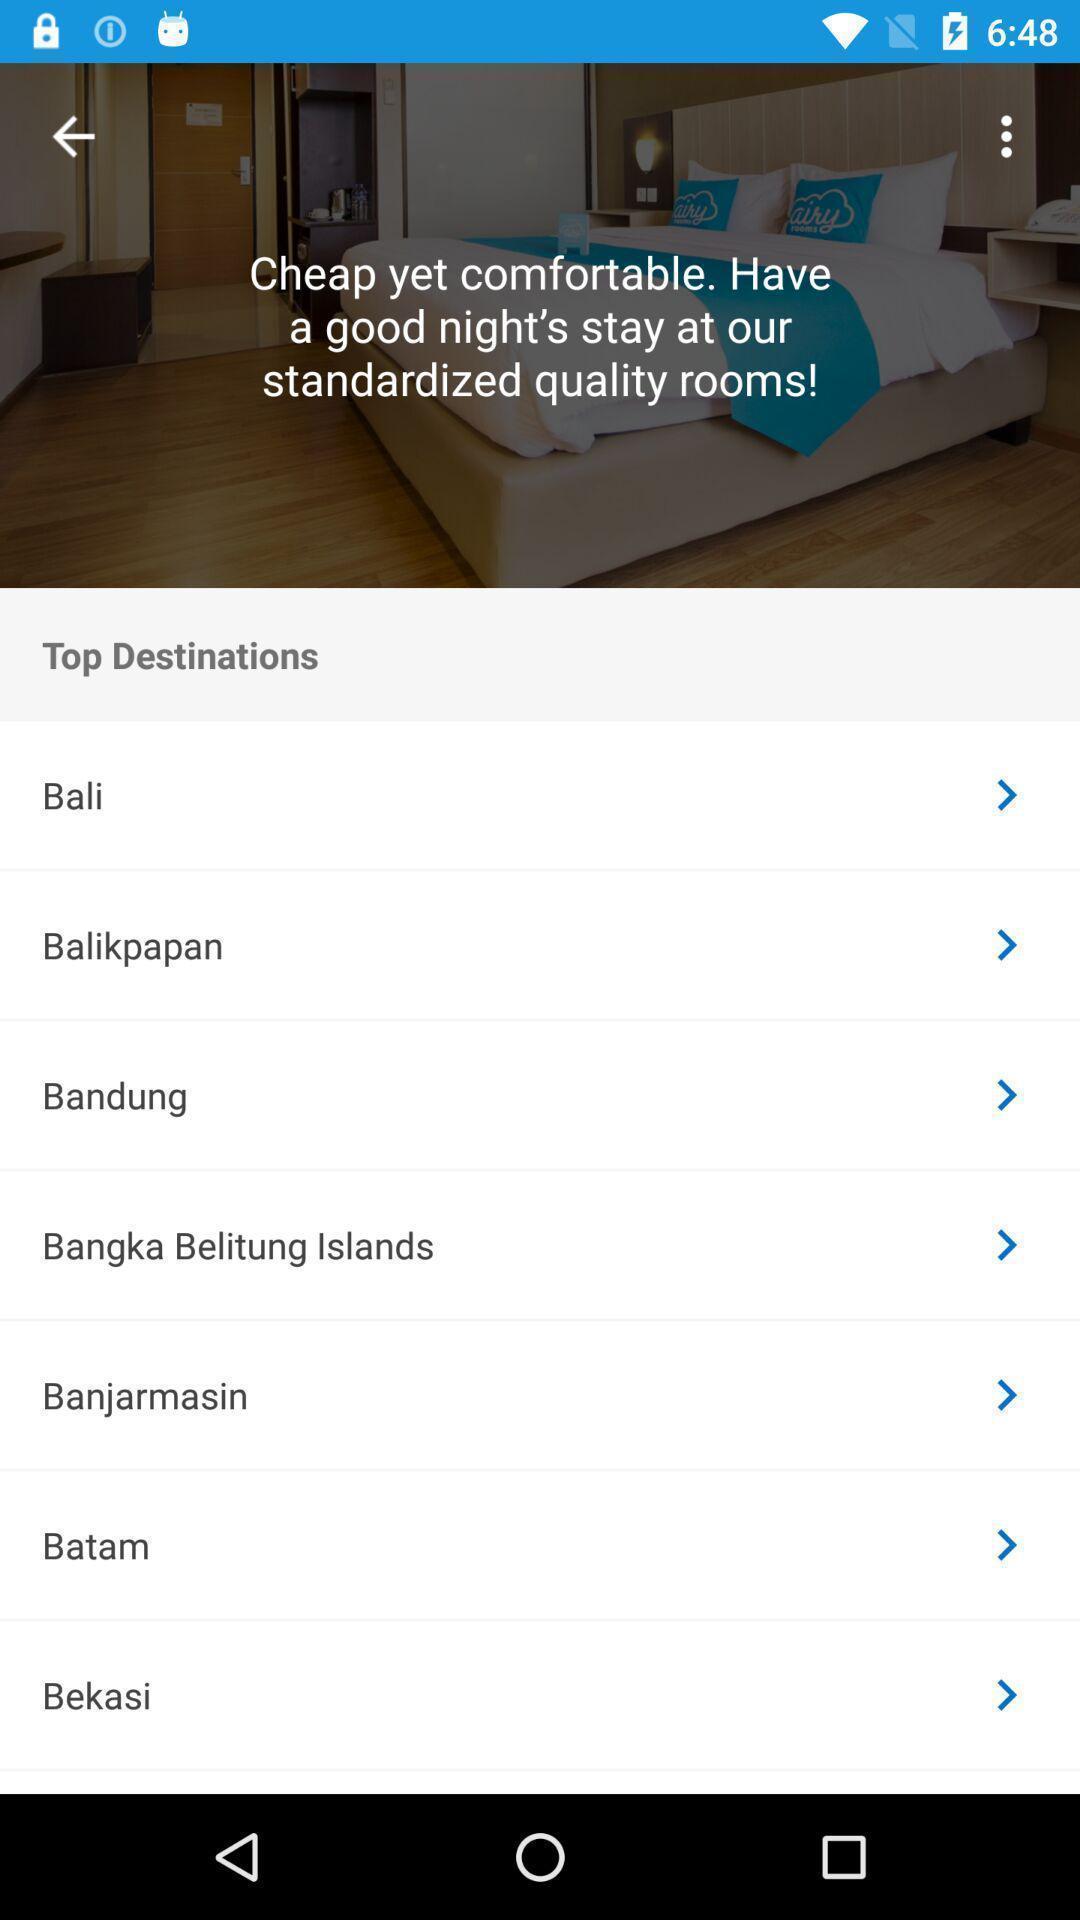Explain what's happening in this screen capture. Page of a travel booking app showing list of destinations. 